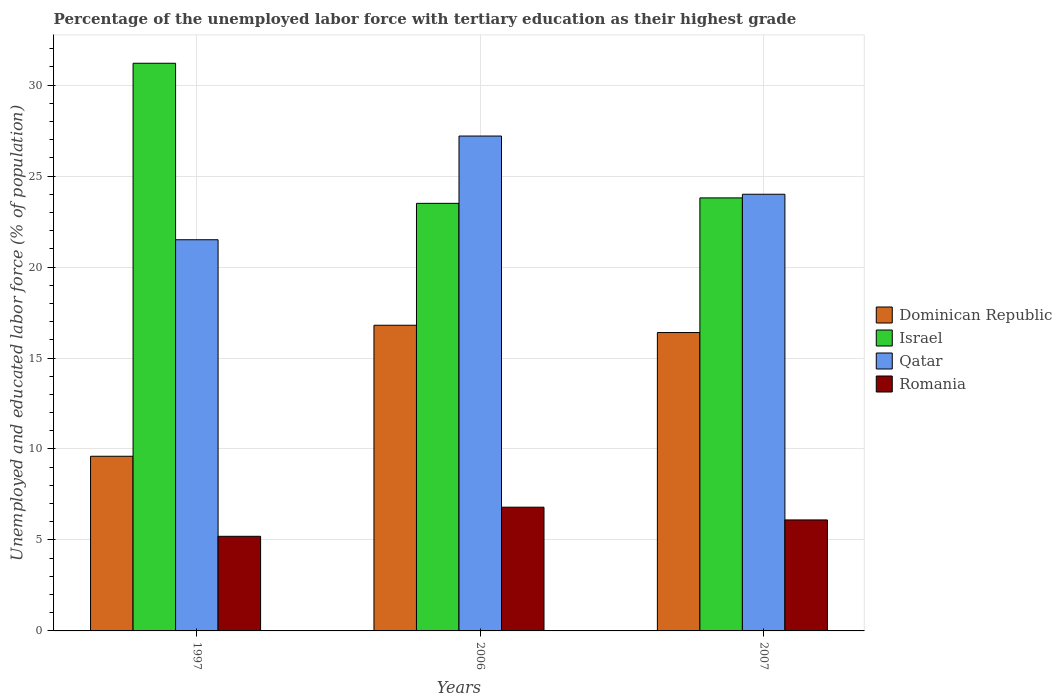Are the number of bars per tick equal to the number of legend labels?
Give a very brief answer. Yes. How many bars are there on the 2nd tick from the left?
Offer a terse response. 4. In how many cases, is the number of bars for a given year not equal to the number of legend labels?
Your answer should be very brief. 0. What is the percentage of the unemployed labor force with tertiary education in Dominican Republic in 1997?
Keep it short and to the point. 9.6. Across all years, what is the maximum percentage of the unemployed labor force with tertiary education in Qatar?
Give a very brief answer. 27.2. What is the total percentage of the unemployed labor force with tertiary education in Qatar in the graph?
Keep it short and to the point. 72.7. What is the difference between the percentage of the unemployed labor force with tertiary education in Israel in 1997 and that in 2007?
Make the answer very short. 7.4. What is the difference between the percentage of the unemployed labor force with tertiary education in Dominican Republic in 2007 and the percentage of the unemployed labor force with tertiary education in Israel in 2006?
Provide a short and direct response. -7.1. What is the average percentage of the unemployed labor force with tertiary education in Dominican Republic per year?
Your response must be concise. 14.27. In the year 2007, what is the difference between the percentage of the unemployed labor force with tertiary education in Dominican Republic and percentage of the unemployed labor force with tertiary education in Romania?
Offer a terse response. 10.3. What is the ratio of the percentage of the unemployed labor force with tertiary education in Romania in 1997 to that in 2007?
Your answer should be very brief. 0.85. Is the difference between the percentage of the unemployed labor force with tertiary education in Dominican Republic in 2006 and 2007 greater than the difference between the percentage of the unemployed labor force with tertiary education in Romania in 2006 and 2007?
Your answer should be very brief. No. What is the difference between the highest and the second highest percentage of the unemployed labor force with tertiary education in Israel?
Give a very brief answer. 7.4. What is the difference between the highest and the lowest percentage of the unemployed labor force with tertiary education in Qatar?
Your answer should be very brief. 5.7. Is the sum of the percentage of the unemployed labor force with tertiary education in Dominican Republic in 1997 and 2007 greater than the maximum percentage of the unemployed labor force with tertiary education in Qatar across all years?
Make the answer very short. No. Is it the case that in every year, the sum of the percentage of the unemployed labor force with tertiary education in Romania and percentage of the unemployed labor force with tertiary education in Qatar is greater than the sum of percentage of the unemployed labor force with tertiary education in Dominican Republic and percentage of the unemployed labor force with tertiary education in Israel?
Provide a short and direct response. Yes. What does the 4th bar from the left in 1997 represents?
Your response must be concise. Romania. What does the 2nd bar from the right in 2007 represents?
Ensure brevity in your answer.  Qatar. Is it the case that in every year, the sum of the percentage of the unemployed labor force with tertiary education in Dominican Republic and percentage of the unemployed labor force with tertiary education in Israel is greater than the percentage of the unemployed labor force with tertiary education in Qatar?
Give a very brief answer. Yes. Where does the legend appear in the graph?
Offer a very short reply. Center right. How many legend labels are there?
Provide a short and direct response. 4. How are the legend labels stacked?
Your response must be concise. Vertical. What is the title of the graph?
Provide a short and direct response. Percentage of the unemployed labor force with tertiary education as their highest grade. Does "Rwanda" appear as one of the legend labels in the graph?
Offer a very short reply. No. What is the label or title of the X-axis?
Make the answer very short. Years. What is the label or title of the Y-axis?
Keep it short and to the point. Unemployed and educated labor force (% of population). What is the Unemployed and educated labor force (% of population) of Dominican Republic in 1997?
Your response must be concise. 9.6. What is the Unemployed and educated labor force (% of population) of Israel in 1997?
Keep it short and to the point. 31.2. What is the Unemployed and educated labor force (% of population) of Qatar in 1997?
Offer a very short reply. 21.5. What is the Unemployed and educated labor force (% of population) in Romania in 1997?
Provide a short and direct response. 5.2. What is the Unemployed and educated labor force (% of population) in Dominican Republic in 2006?
Offer a very short reply. 16.8. What is the Unemployed and educated labor force (% of population) in Qatar in 2006?
Make the answer very short. 27.2. What is the Unemployed and educated labor force (% of population) in Romania in 2006?
Provide a short and direct response. 6.8. What is the Unemployed and educated labor force (% of population) in Dominican Republic in 2007?
Provide a succinct answer. 16.4. What is the Unemployed and educated labor force (% of population) in Israel in 2007?
Ensure brevity in your answer.  23.8. What is the Unemployed and educated labor force (% of population) in Romania in 2007?
Your answer should be compact. 6.1. Across all years, what is the maximum Unemployed and educated labor force (% of population) in Dominican Republic?
Keep it short and to the point. 16.8. Across all years, what is the maximum Unemployed and educated labor force (% of population) of Israel?
Provide a succinct answer. 31.2. Across all years, what is the maximum Unemployed and educated labor force (% of population) in Qatar?
Your response must be concise. 27.2. Across all years, what is the maximum Unemployed and educated labor force (% of population) in Romania?
Keep it short and to the point. 6.8. Across all years, what is the minimum Unemployed and educated labor force (% of population) in Dominican Republic?
Your answer should be compact. 9.6. Across all years, what is the minimum Unemployed and educated labor force (% of population) in Romania?
Provide a succinct answer. 5.2. What is the total Unemployed and educated labor force (% of population) in Dominican Republic in the graph?
Your response must be concise. 42.8. What is the total Unemployed and educated labor force (% of population) of Israel in the graph?
Give a very brief answer. 78.5. What is the total Unemployed and educated labor force (% of population) in Qatar in the graph?
Offer a very short reply. 72.7. What is the total Unemployed and educated labor force (% of population) of Romania in the graph?
Provide a succinct answer. 18.1. What is the difference between the Unemployed and educated labor force (% of population) in Dominican Republic in 1997 and that in 2006?
Ensure brevity in your answer.  -7.2. What is the difference between the Unemployed and educated labor force (% of population) in Israel in 1997 and that in 2006?
Your answer should be very brief. 7.7. What is the difference between the Unemployed and educated labor force (% of population) in Qatar in 1997 and that in 2006?
Ensure brevity in your answer.  -5.7. What is the difference between the Unemployed and educated labor force (% of population) of Dominican Republic in 1997 and the Unemployed and educated labor force (% of population) of Israel in 2006?
Offer a terse response. -13.9. What is the difference between the Unemployed and educated labor force (% of population) of Dominican Republic in 1997 and the Unemployed and educated labor force (% of population) of Qatar in 2006?
Keep it short and to the point. -17.6. What is the difference between the Unemployed and educated labor force (% of population) in Israel in 1997 and the Unemployed and educated labor force (% of population) in Romania in 2006?
Give a very brief answer. 24.4. What is the difference between the Unemployed and educated labor force (% of population) in Dominican Republic in 1997 and the Unemployed and educated labor force (% of population) in Qatar in 2007?
Make the answer very short. -14.4. What is the difference between the Unemployed and educated labor force (% of population) of Dominican Republic in 1997 and the Unemployed and educated labor force (% of population) of Romania in 2007?
Give a very brief answer. 3.5. What is the difference between the Unemployed and educated labor force (% of population) of Israel in 1997 and the Unemployed and educated labor force (% of population) of Romania in 2007?
Keep it short and to the point. 25.1. What is the difference between the Unemployed and educated labor force (% of population) in Qatar in 1997 and the Unemployed and educated labor force (% of population) in Romania in 2007?
Provide a short and direct response. 15.4. What is the difference between the Unemployed and educated labor force (% of population) of Dominican Republic in 2006 and the Unemployed and educated labor force (% of population) of Qatar in 2007?
Keep it short and to the point. -7.2. What is the difference between the Unemployed and educated labor force (% of population) in Israel in 2006 and the Unemployed and educated labor force (% of population) in Qatar in 2007?
Provide a short and direct response. -0.5. What is the difference between the Unemployed and educated labor force (% of population) of Israel in 2006 and the Unemployed and educated labor force (% of population) of Romania in 2007?
Provide a short and direct response. 17.4. What is the difference between the Unemployed and educated labor force (% of population) in Qatar in 2006 and the Unemployed and educated labor force (% of population) in Romania in 2007?
Make the answer very short. 21.1. What is the average Unemployed and educated labor force (% of population) in Dominican Republic per year?
Make the answer very short. 14.27. What is the average Unemployed and educated labor force (% of population) of Israel per year?
Your response must be concise. 26.17. What is the average Unemployed and educated labor force (% of population) of Qatar per year?
Your answer should be very brief. 24.23. What is the average Unemployed and educated labor force (% of population) of Romania per year?
Keep it short and to the point. 6.03. In the year 1997, what is the difference between the Unemployed and educated labor force (% of population) of Dominican Republic and Unemployed and educated labor force (% of population) of Israel?
Make the answer very short. -21.6. In the year 1997, what is the difference between the Unemployed and educated labor force (% of population) in Qatar and Unemployed and educated labor force (% of population) in Romania?
Make the answer very short. 16.3. In the year 2006, what is the difference between the Unemployed and educated labor force (% of population) of Dominican Republic and Unemployed and educated labor force (% of population) of Israel?
Keep it short and to the point. -6.7. In the year 2006, what is the difference between the Unemployed and educated labor force (% of population) in Dominican Republic and Unemployed and educated labor force (% of population) in Romania?
Your response must be concise. 10. In the year 2006, what is the difference between the Unemployed and educated labor force (% of population) in Israel and Unemployed and educated labor force (% of population) in Qatar?
Keep it short and to the point. -3.7. In the year 2006, what is the difference between the Unemployed and educated labor force (% of population) in Qatar and Unemployed and educated labor force (% of population) in Romania?
Offer a terse response. 20.4. In the year 2007, what is the difference between the Unemployed and educated labor force (% of population) in Dominican Republic and Unemployed and educated labor force (% of population) in Israel?
Keep it short and to the point. -7.4. In the year 2007, what is the difference between the Unemployed and educated labor force (% of population) in Dominican Republic and Unemployed and educated labor force (% of population) in Qatar?
Offer a very short reply. -7.6. In the year 2007, what is the difference between the Unemployed and educated labor force (% of population) of Dominican Republic and Unemployed and educated labor force (% of population) of Romania?
Provide a short and direct response. 10.3. In the year 2007, what is the difference between the Unemployed and educated labor force (% of population) of Israel and Unemployed and educated labor force (% of population) of Qatar?
Make the answer very short. -0.2. In the year 2007, what is the difference between the Unemployed and educated labor force (% of population) of Israel and Unemployed and educated labor force (% of population) of Romania?
Your response must be concise. 17.7. In the year 2007, what is the difference between the Unemployed and educated labor force (% of population) of Qatar and Unemployed and educated labor force (% of population) of Romania?
Keep it short and to the point. 17.9. What is the ratio of the Unemployed and educated labor force (% of population) in Dominican Republic in 1997 to that in 2006?
Provide a succinct answer. 0.57. What is the ratio of the Unemployed and educated labor force (% of population) of Israel in 1997 to that in 2006?
Your response must be concise. 1.33. What is the ratio of the Unemployed and educated labor force (% of population) in Qatar in 1997 to that in 2006?
Offer a terse response. 0.79. What is the ratio of the Unemployed and educated labor force (% of population) of Romania in 1997 to that in 2006?
Your answer should be compact. 0.76. What is the ratio of the Unemployed and educated labor force (% of population) in Dominican Republic in 1997 to that in 2007?
Keep it short and to the point. 0.59. What is the ratio of the Unemployed and educated labor force (% of population) in Israel in 1997 to that in 2007?
Offer a very short reply. 1.31. What is the ratio of the Unemployed and educated labor force (% of population) of Qatar in 1997 to that in 2007?
Make the answer very short. 0.9. What is the ratio of the Unemployed and educated labor force (% of population) of Romania in 1997 to that in 2007?
Offer a terse response. 0.85. What is the ratio of the Unemployed and educated labor force (% of population) of Dominican Republic in 2006 to that in 2007?
Your response must be concise. 1.02. What is the ratio of the Unemployed and educated labor force (% of population) of Israel in 2006 to that in 2007?
Provide a succinct answer. 0.99. What is the ratio of the Unemployed and educated labor force (% of population) of Qatar in 2006 to that in 2007?
Your answer should be compact. 1.13. What is the ratio of the Unemployed and educated labor force (% of population) of Romania in 2006 to that in 2007?
Ensure brevity in your answer.  1.11. What is the difference between the highest and the lowest Unemployed and educated labor force (% of population) of Israel?
Provide a short and direct response. 7.7. What is the difference between the highest and the lowest Unemployed and educated labor force (% of population) in Qatar?
Ensure brevity in your answer.  5.7. What is the difference between the highest and the lowest Unemployed and educated labor force (% of population) of Romania?
Ensure brevity in your answer.  1.6. 